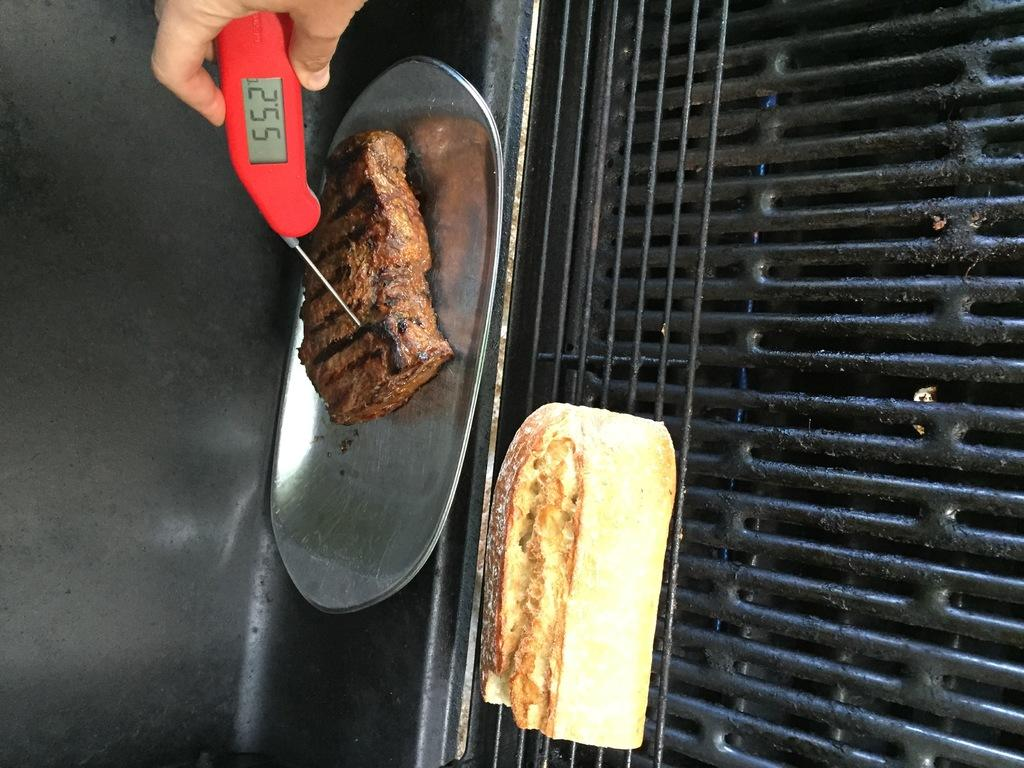<image>
Create a compact narrative representing the image presented. a grill with meat and thermometer reading 55.2 